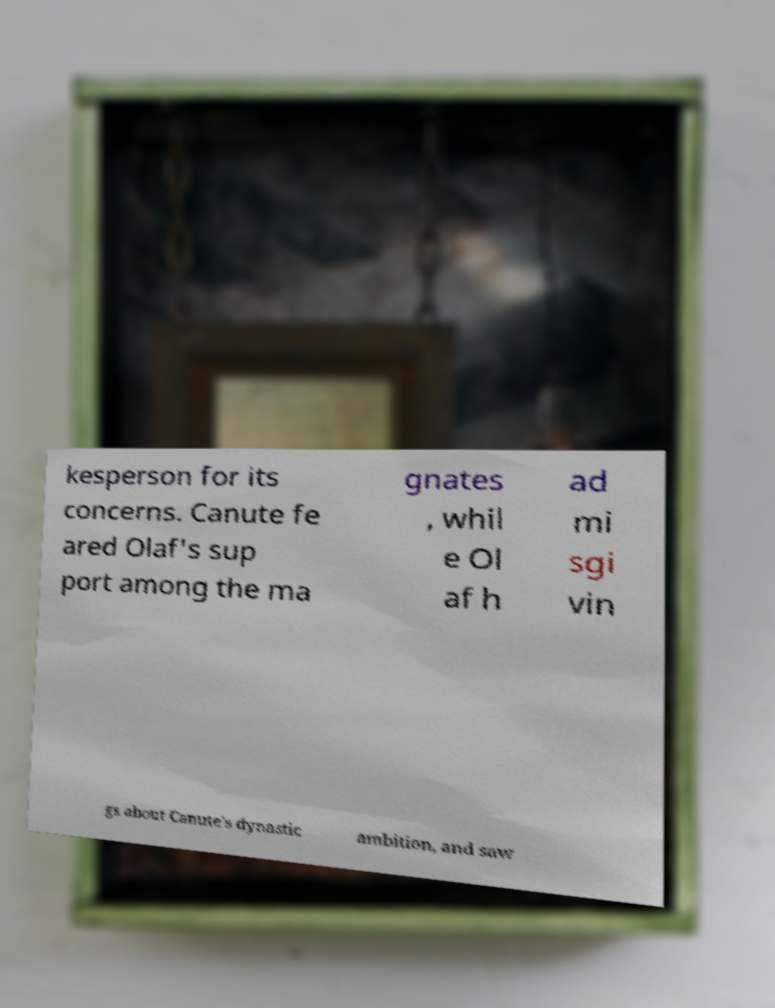Could you assist in decoding the text presented in this image and type it out clearly? kesperson for its concerns. Canute fe ared Olaf's sup port among the ma gnates , whil e Ol af h ad mi sgi vin gs about Canute's dynastic ambition, and saw 